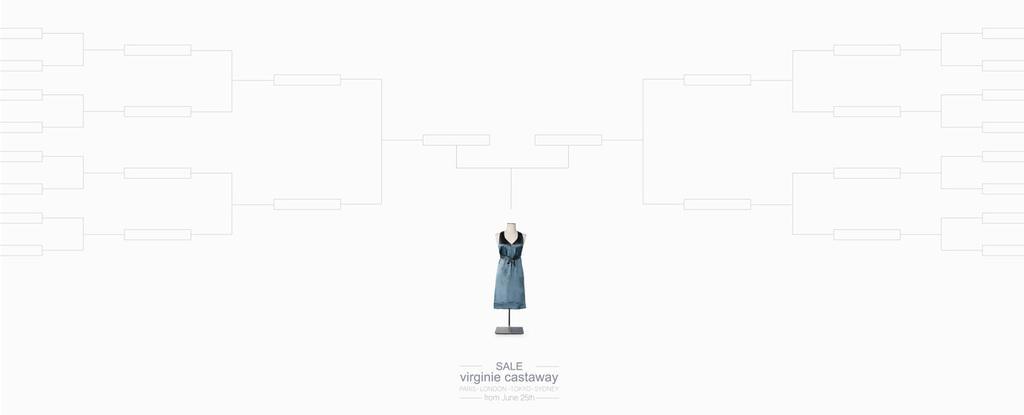Describe this image in one or two sentences. In the picture I can see a dress to the mannequin. Here I can see some edited text at the bottom of the image and I can see some black color lines on the white color background. 